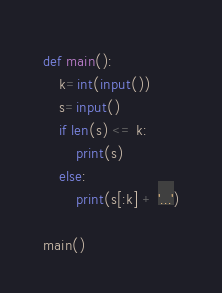Convert code to text. <code><loc_0><loc_0><loc_500><loc_500><_Python_>def main():
    k=int(input())
    s=input()
    if len(s) <= k:
        print(s)
    else:
        print(s[:k] + '...')

main()</code> 